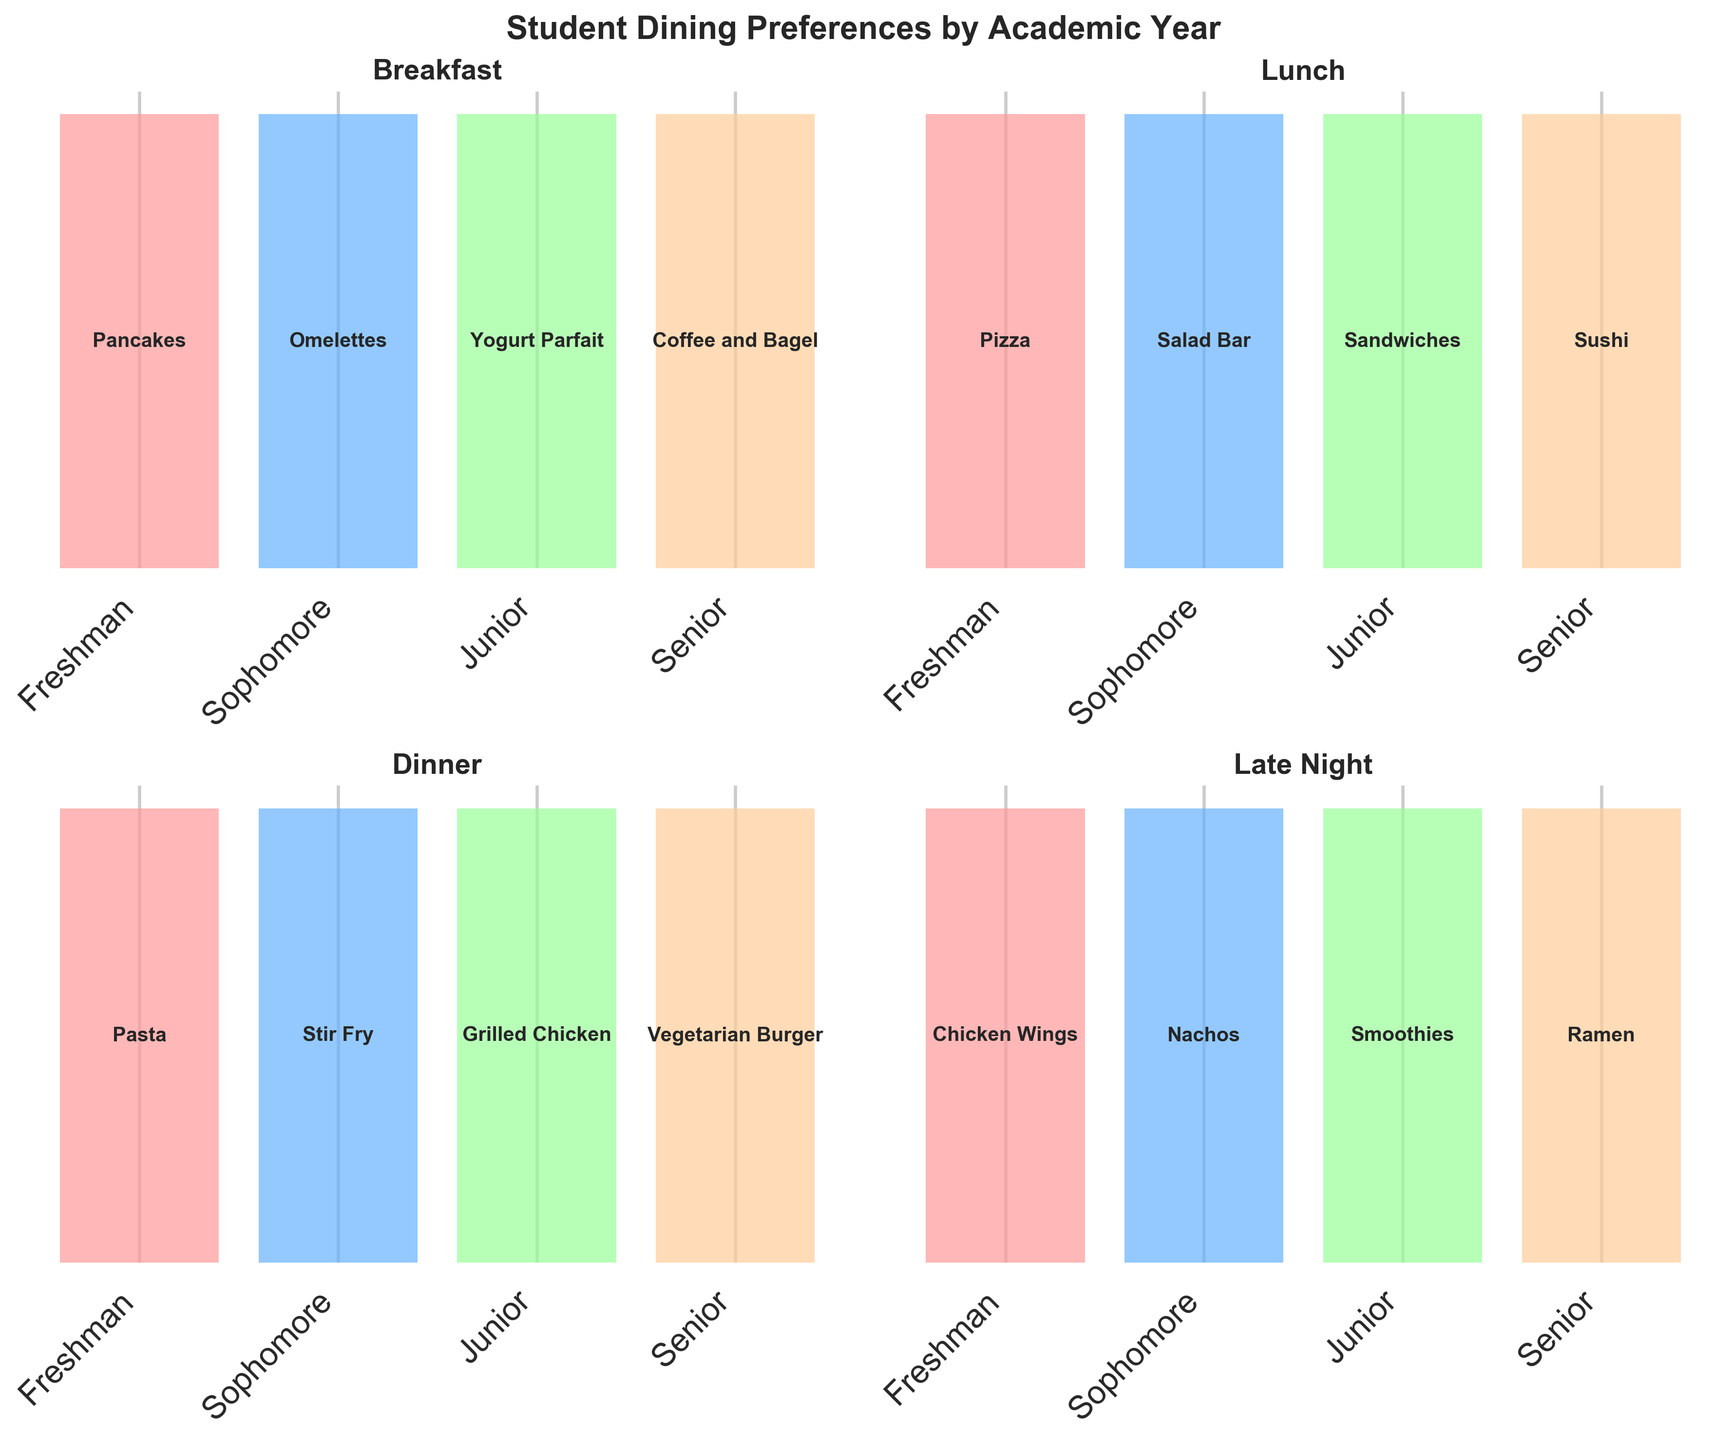what is the most popular breakfast item for seniors? The "Breakfast" subplot shows the breakdown of preferences by year. By looking at the Seniors bar, the text states the most popular breakfast item.
Answer: Coffee and Bagel which year prefers salads over other lunch options? The "Lunch" subplot shows the breakdown of preferences by year. By identifying the year with "Salad Bar" above its bar, we find the answer.
Answer: Sophomore which meal type has the most varied preferences across different academic years? Examine each subplot and see where the preferences change the most across different academic years. The "Late Night" meal type shows significant variation compared to others.
Answer: Late Night which year has a tendency to prefer vegetarian options for dinner? The "Dinner" subplot shows the breakdown of preferences by year. Seniors' preference is for "Vegetarian Burger," showing their tendency towards vegetarian options.
Answer: Senior for juniors, is there a meal type where their preference is a type of drink? Check each meal type for Juniors and see if any preference is a drink. "Late Night" preferences show that Juniors prefer "Smoothies."
Answer: Yes which meal type have the most uniform preferences (i.e., less variety) across different academic years? Examine each subplot and see where the preferences change the least across different academic years. The "Lunch" meal type shows less variety compared to others.
Answer: Lunch what is the least popular dinner item among juniors? The "Dinner" subplot shows the breakdown of preferences by year. The preferred item for Juniors can be seen above its respective bar; since the least popular doesn't apply directly, we infer by stepping outside usual preferences — Juniors show a preference for "Grilled Chicken," which might imply the least among the others.
Answer: Pasta / Stir Fry (inferred) what are the favorite meal options for freshmen for all meal types combined? Examine each subplot (Breakfast, Lunch, Dinner, Late Night) and list the preferences indicated for Freshmen.
Answer: Pancakes, Pizza, Pasta, Chicken Wings what lunch option do seniors prefer the most? The "Lunch" subplot shows the breakdown of preferences by year. The bar for Seniors has "Sushi" above it, indicating their preference.
Answer: Sushi do sophomores and juniors share any popular dining preferences across different meal types? Compare preferences of Sophomores and Juniors across all subplots. There are no shared preferences between Sophomores and Juniors in the provided data.
Answer: No 